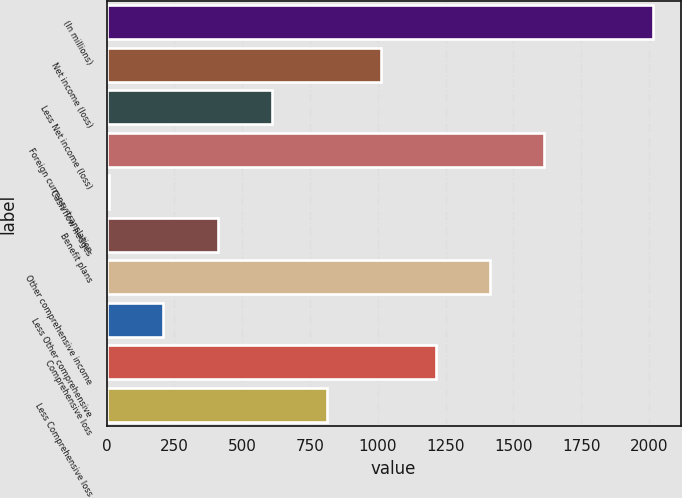Convert chart to OTSL. <chart><loc_0><loc_0><loc_500><loc_500><bar_chart><fcel>(In millions)<fcel>Net income (loss)<fcel>Less Net income (loss)<fcel>Foreign currency translation<fcel>Cash flow hedges<fcel>Benefit plans<fcel>Other comprehensive income<fcel>Less Other comprehensive<fcel>Comprehensive loss<fcel>Less Comprehensive loss<nl><fcel>2016<fcel>1012<fcel>610.4<fcel>1614.4<fcel>8<fcel>409.6<fcel>1413.6<fcel>208.8<fcel>1212.8<fcel>811.2<nl></chart> 